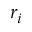<formula> <loc_0><loc_0><loc_500><loc_500>r _ { i }</formula> 